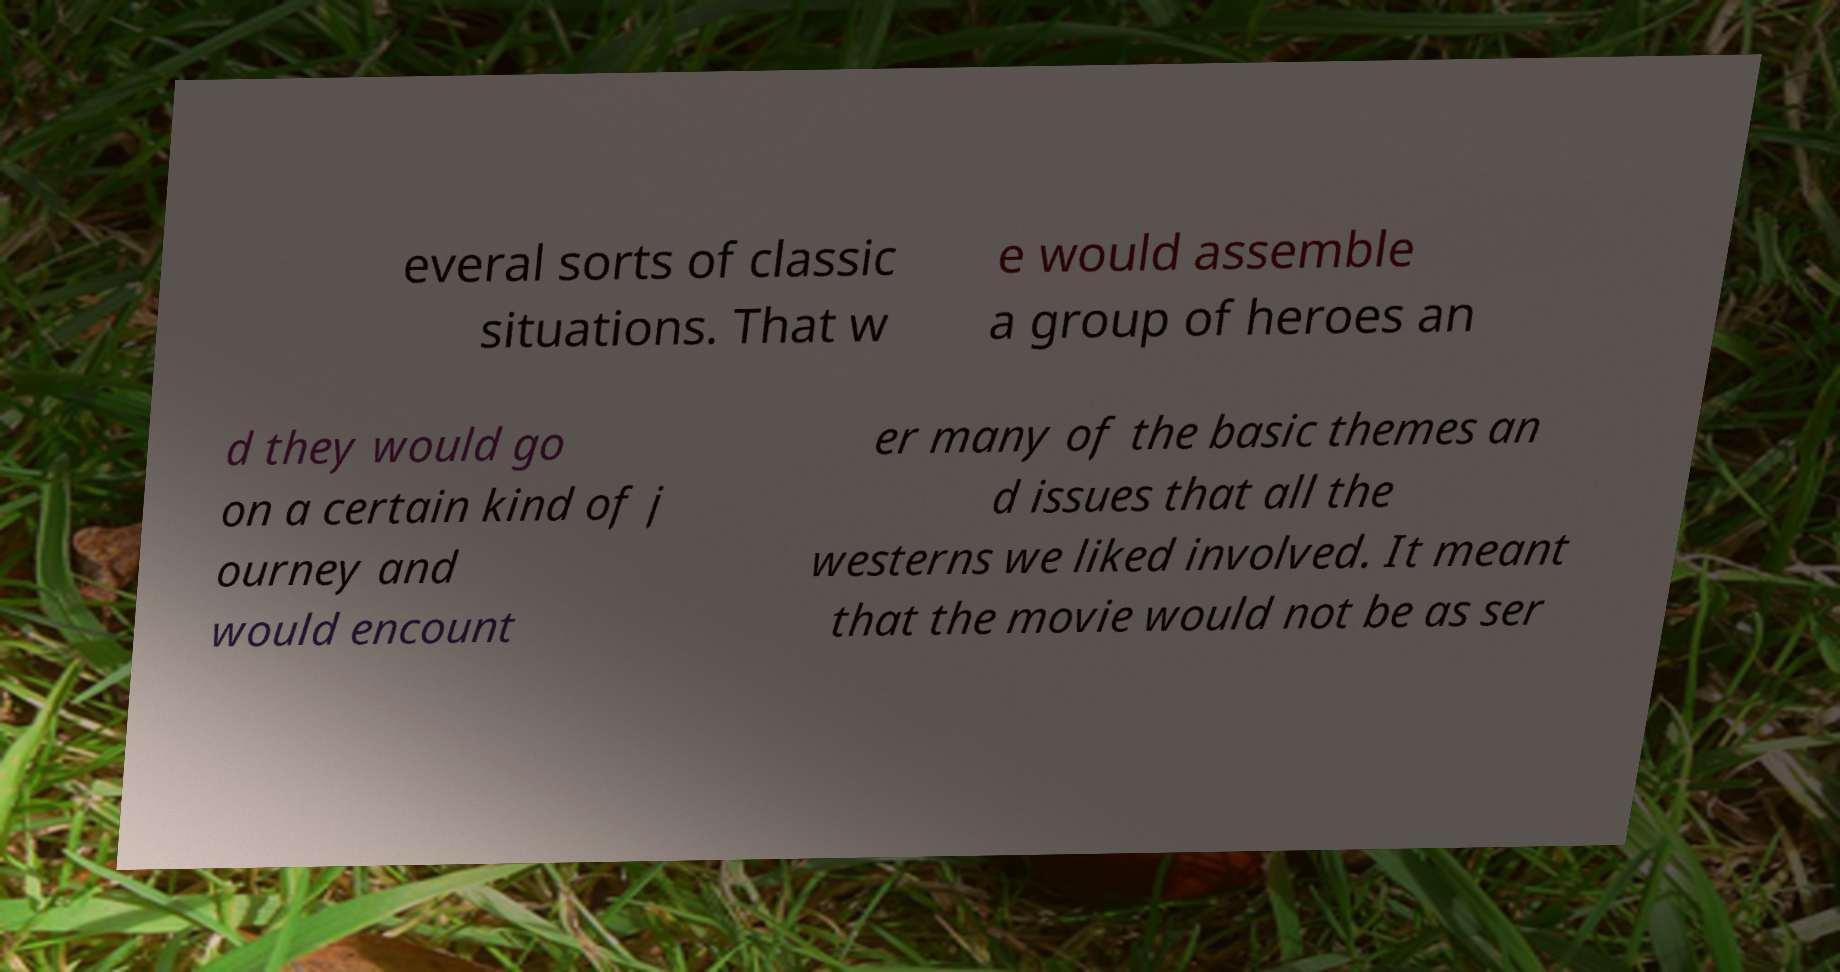What messages or text are displayed in this image? I need them in a readable, typed format. everal sorts of classic situations. That w e would assemble a group of heroes an d they would go on a certain kind of j ourney and would encount er many of the basic themes an d issues that all the westerns we liked involved. It meant that the movie would not be as ser 